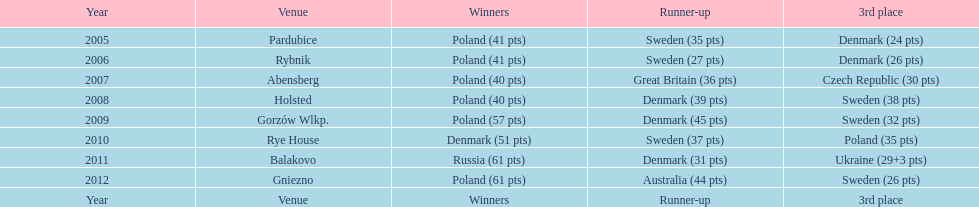Between 2005 and 2012, which team secured the highest number of third-place finishes in the speedway junior world championship? Sweden. I'm looking to parse the entire table for insights. Could you assist me with that? {'header': ['Year', 'Venue', 'Winners', 'Runner-up', '3rd place'], 'rows': [['2005', 'Pardubice', 'Poland (41 pts)', 'Sweden (35 pts)', 'Denmark (24 pts)'], ['2006', 'Rybnik', 'Poland (41 pts)', 'Sweden (27 pts)', 'Denmark (26 pts)'], ['2007', 'Abensberg', 'Poland (40 pts)', 'Great Britain (36 pts)', 'Czech Republic (30 pts)'], ['2008', 'Holsted', 'Poland (40 pts)', 'Denmark (39 pts)', 'Sweden (38 pts)'], ['2009', 'Gorzów Wlkp.', 'Poland (57 pts)', 'Denmark (45 pts)', 'Sweden (32 pts)'], ['2010', 'Rye House', 'Denmark (51 pts)', 'Sweden (37 pts)', 'Poland (35 pts)'], ['2011', 'Balakovo', 'Russia (61 pts)', 'Denmark (31 pts)', 'Ukraine (29+3 pts)'], ['2012', 'Gniezno', 'Poland (61 pts)', 'Australia (44 pts)', 'Sweden (26 pts)'], ['Year', 'Venue', 'Winners', 'Runner-up', '3rd place']]} 